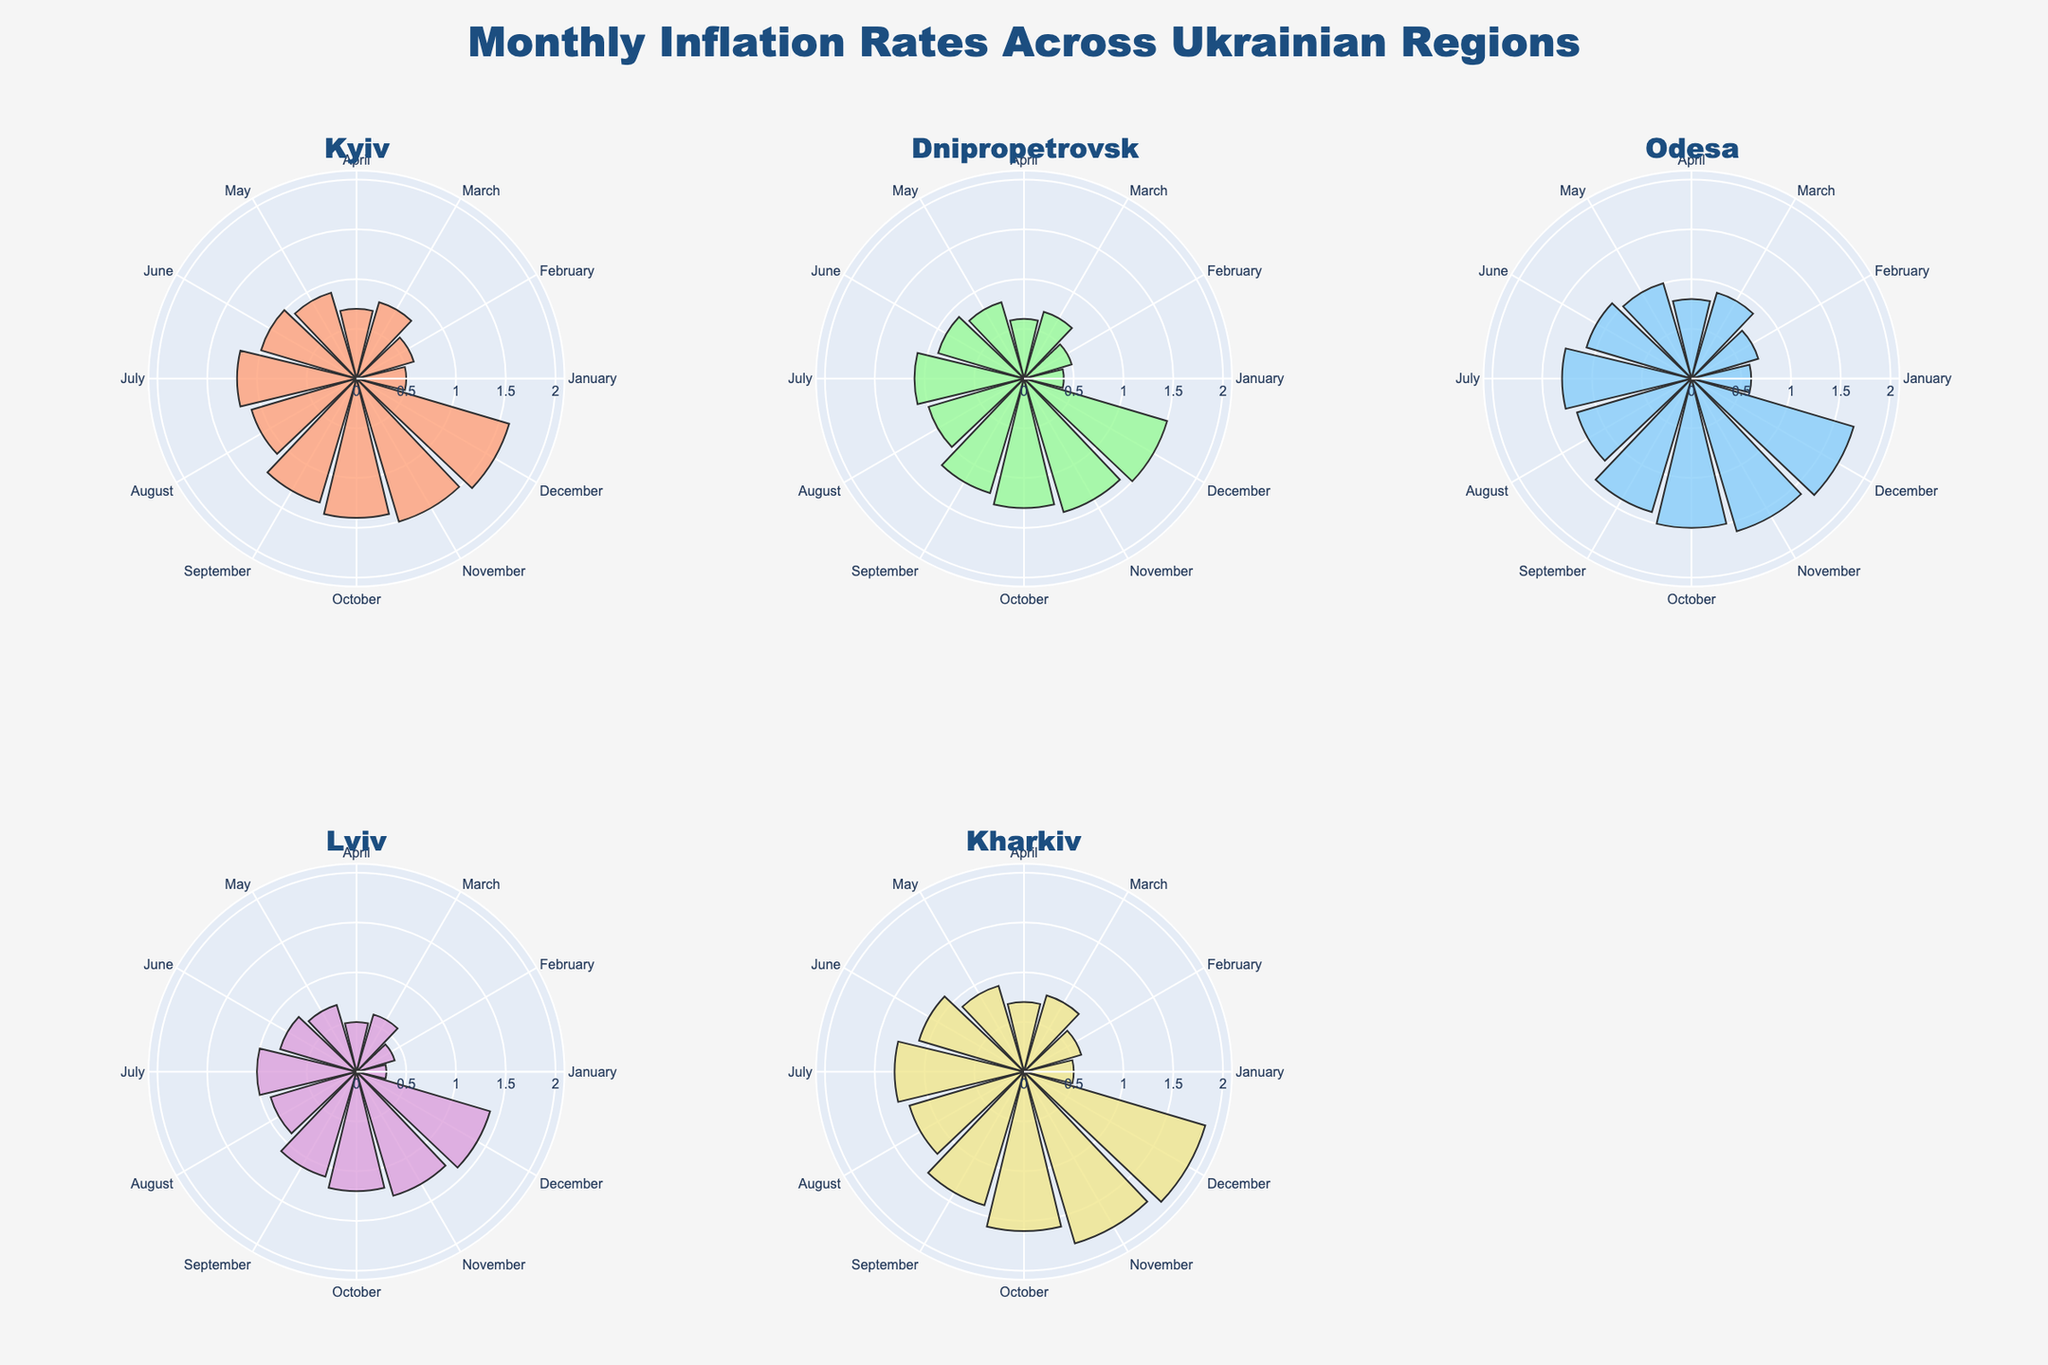Which region had the highest inflation rate in December? To identify the region with the highest inflation rate in December, look at the figure and find which bar is longest for December. The longest bar for December belongs to Odesa.
Answer: Odesa Which month had the lowest inflation rate in Lviv? To find the month with the lowest inflation rate in Lviv, compare the lengths of the bars for all months in the subplot for Lviv. The shortest bar is in January.
Answer: January Which region showed the most consistent monthly inflation rate throughout the year? Consistency in monthly inflation rates can be observed by examining the evenness in bar heights for each month's subplot. Kyiv shows the most consistent rate, since the heights of its bars are more uniform.
Answer: Kyiv How does the inflation rate in July compare between Kharkiv and Dnipropetrovsk? To compare the inflation rates in July between Kharkiv and Dnipropetrovsk, look at the bar heights for July in their respective subplots. Kharkiv has a longer bar indicating a higher rate.
Answer: Higher in Kharkiv What's the average inflation rate in Kyiv for the first quarter (January to March)? Calculate the average by summing the inflation rates of Kyiv from January to March (0.5 + 0.6 + 0.8) and then dividing by 3.
Answer: 0.63 Which region experienced the largest increase in inflation rate from June to July? To find which region had the largest increase, calculate the difference in bar heights between June and July for each region. Kharkiv saw an increase from 1.1 to 1.3 which is the largest.
Answer: Kharkiv In which month did Odesa have the highest inflation rate? To find the month with the highest inflation rate in Odesa, find the longest bar in Odesa's subplot. The longest bar is in December.
Answer: December Compare the inflation rates in October across all regions. Which region had the highest rate? In October, compare the bar heights across all regions. Kharkiv has the highest bar indicating the highest inflation rate.
Answer: Kharkiv Which region had a constant increase in inflation rates month over month? A constant increase can be observed by checking for a uniform upward trend in bar heights. None of the regions have a completely constant increase, but Kharkiv has a mostly upward trend with slight variations.
Answer: Kharkiv 